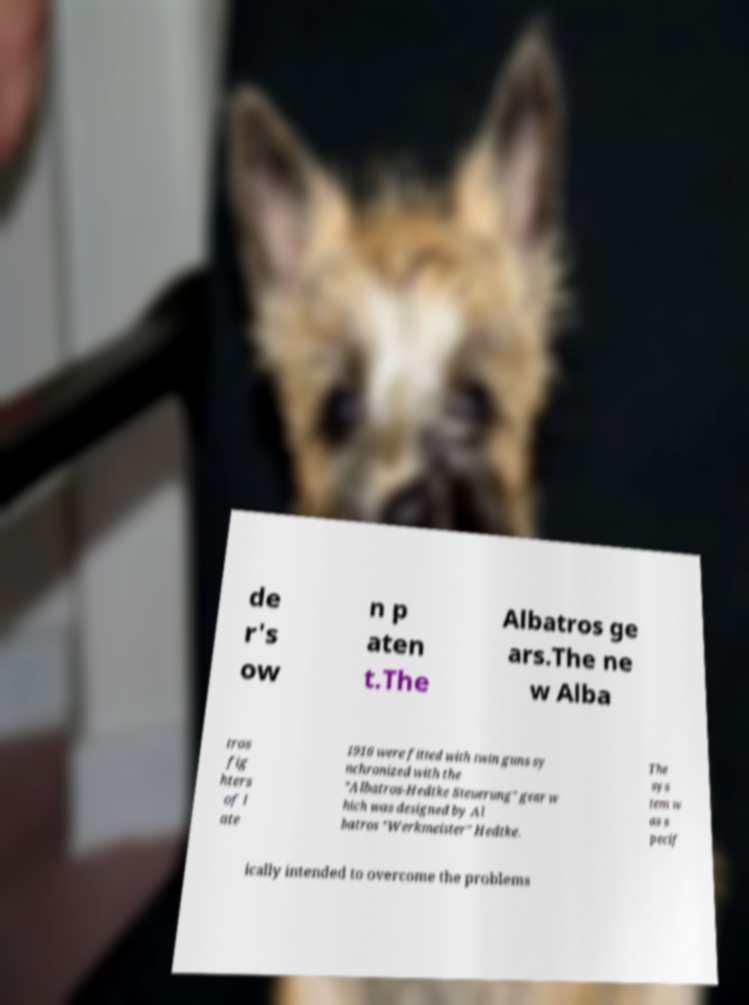Could you assist in decoding the text presented in this image and type it out clearly? de r's ow n p aten t.The Albatros ge ars.The ne w Alba tros fig hters of l ate 1916 were fitted with twin guns sy nchronized with the "Albatros-Hedtke Steuerung" gear w hich was designed by Al batros "Werkmeister" Hedtke. The sys tem w as s pecif ically intended to overcome the problems 